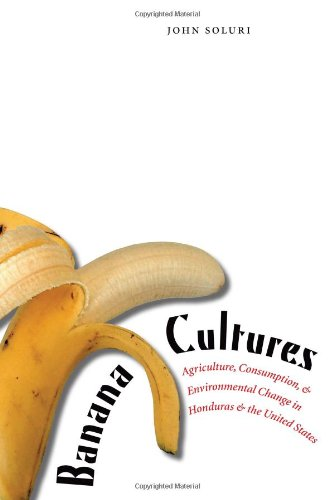How does the book link the consumption in the United States to changes in Honduras? It explores the intricate economic relationships that tie U.S. consumer habits with agricultural practices in Honduras, leading to significant socio-economic and environmental shifts in the region. 